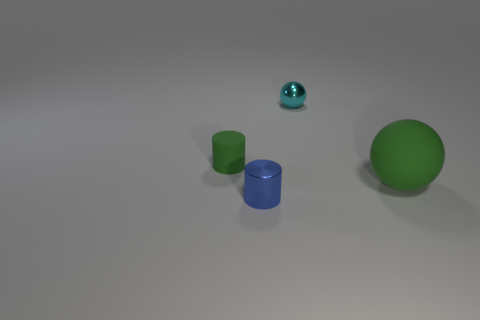Add 4 blue cylinders. How many objects exist? 8 Add 1 big green blocks. How many big green blocks exist? 1 Subtract 0 brown blocks. How many objects are left? 4 Subtract all balls. Subtract all balls. How many objects are left? 0 Add 1 small blue things. How many small blue things are left? 2 